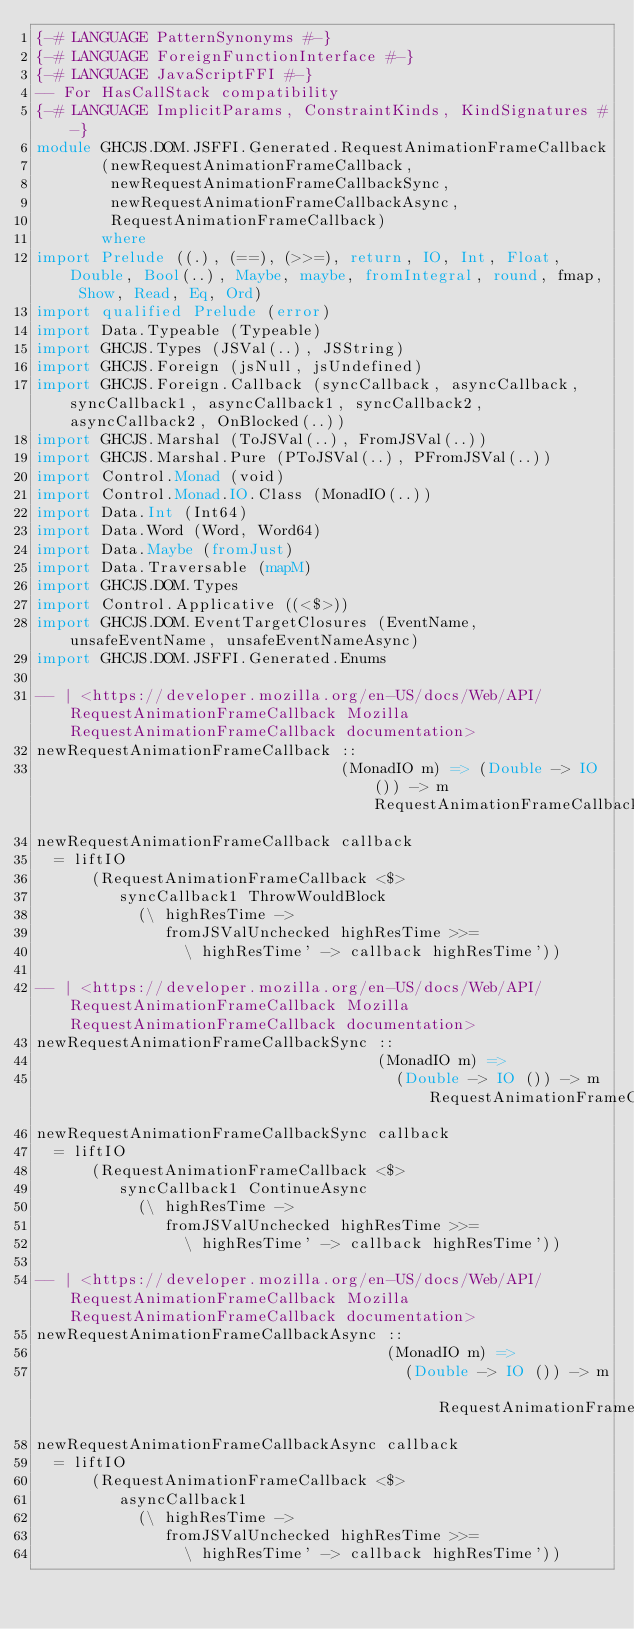Convert code to text. <code><loc_0><loc_0><loc_500><loc_500><_Haskell_>{-# LANGUAGE PatternSynonyms #-}
{-# LANGUAGE ForeignFunctionInterface #-}
{-# LANGUAGE JavaScriptFFI #-}
-- For HasCallStack compatibility
{-# LANGUAGE ImplicitParams, ConstraintKinds, KindSignatures #-}
module GHCJS.DOM.JSFFI.Generated.RequestAnimationFrameCallback
       (newRequestAnimationFrameCallback,
        newRequestAnimationFrameCallbackSync,
        newRequestAnimationFrameCallbackAsync,
        RequestAnimationFrameCallback)
       where
import Prelude ((.), (==), (>>=), return, IO, Int, Float, Double, Bool(..), Maybe, maybe, fromIntegral, round, fmap, Show, Read, Eq, Ord)
import qualified Prelude (error)
import Data.Typeable (Typeable)
import GHCJS.Types (JSVal(..), JSString)
import GHCJS.Foreign (jsNull, jsUndefined)
import GHCJS.Foreign.Callback (syncCallback, asyncCallback, syncCallback1, asyncCallback1, syncCallback2, asyncCallback2, OnBlocked(..))
import GHCJS.Marshal (ToJSVal(..), FromJSVal(..))
import GHCJS.Marshal.Pure (PToJSVal(..), PFromJSVal(..))
import Control.Monad (void)
import Control.Monad.IO.Class (MonadIO(..))
import Data.Int (Int64)
import Data.Word (Word, Word64)
import Data.Maybe (fromJust)
import Data.Traversable (mapM)
import GHCJS.DOM.Types
import Control.Applicative ((<$>))
import GHCJS.DOM.EventTargetClosures (EventName, unsafeEventName, unsafeEventNameAsync)
import GHCJS.DOM.JSFFI.Generated.Enums

-- | <https://developer.mozilla.org/en-US/docs/Web/API/RequestAnimationFrameCallback Mozilla RequestAnimationFrameCallback documentation> 
newRequestAnimationFrameCallback ::
                                 (MonadIO m) => (Double -> IO ()) -> m RequestAnimationFrameCallback
newRequestAnimationFrameCallback callback
  = liftIO
      (RequestAnimationFrameCallback <$>
         syncCallback1 ThrowWouldBlock
           (\ highResTime ->
              fromJSValUnchecked highResTime >>=
                \ highResTime' -> callback highResTime'))

-- | <https://developer.mozilla.org/en-US/docs/Web/API/RequestAnimationFrameCallback Mozilla RequestAnimationFrameCallback documentation> 
newRequestAnimationFrameCallbackSync ::
                                     (MonadIO m) =>
                                       (Double -> IO ()) -> m RequestAnimationFrameCallback
newRequestAnimationFrameCallbackSync callback
  = liftIO
      (RequestAnimationFrameCallback <$>
         syncCallback1 ContinueAsync
           (\ highResTime ->
              fromJSValUnchecked highResTime >>=
                \ highResTime' -> callback highResTime'))

-- | <https://developer.mozilla.org/en-US/docs/Web/API/RequestAnimationFrameCallback Mozilla RequestAnimationFrameCallback documentation> 
newRequestAnimationFrameCallbackAsync ::
                                      (MonadIO m) =>
                                        (Double -> IO ()) -> m RequestAnimationFrameCallback
newRequestAnimationFrameCallbackAsync callback
  = liftIO
      (RequestAnimationFrameCallback <$>
         asyncCallback1
           (\ highResTime ->
              fromJSValUnchecked highResTime >>=
                \ highResTime' -> callback highResTime'))</code> 